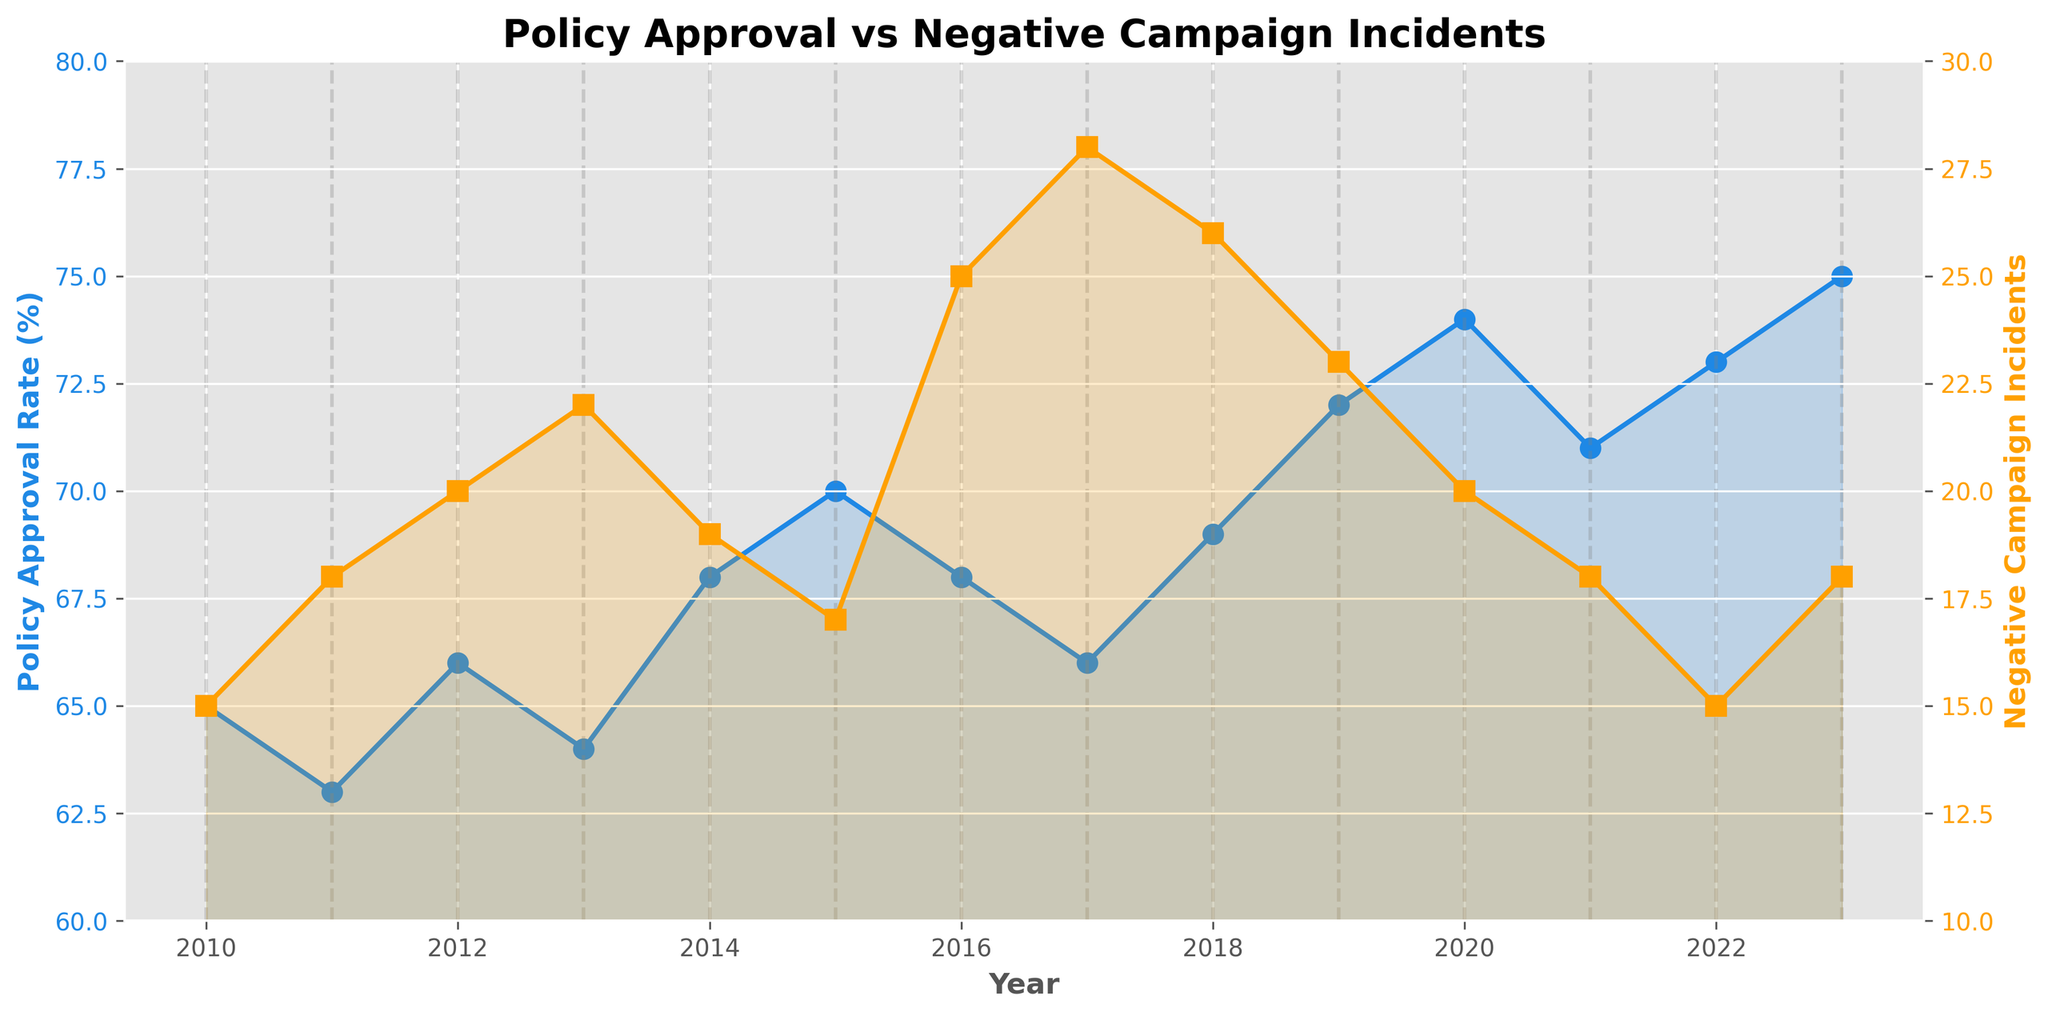What's the title of the figure? The title of the figure is placed at the top.
Answer: Policy Approval vs Negative Campaign Incidents What are the two y-axes representing? The left y-axis (colored in blue) represents the Policy Approval Rate (%), and the right y-axis (colored in orange) represents the Number of Negative Campaign Incidents.
Answer: Policy Approval Rate (%) and Negative Campaign Incidents In which year was the policy approval rate highest? Look at the highest point of the blue line (Policy Approval Rate) and check the corresponding year on the x-axis.
Answer: 2023 How did the number of negative campaign incidents change between 2010 and 2013? Find the points for 2010 and 2013 on the orange line (Negative Campaign Incidents) and note their values. Compare the two values to see the change.
Answer: Increased from 15 to 22 What is the average policy approval rate over the years shown? Add all the Policy Approval Rate values and divide by the number of years (14).
Answer: (65+63+66+64+68+70+68+66+69+72+74+71+73+75) / 14 = 68.5 Which year had the lowest number of negative campaign incidents? Identify the lowest point on the orange line and note the corresponding year on the x-axis.
Answer: 2010 Was the policy approval rate generally trending upwards or downwards? Observe the general direction of the blue line. If it moves higher as the years progress, it trends upwards; otherwise, it trends downwards.
Answer: Upwards What was the difference in policy approval rate between the year with the highest incidents of negative campaigns and the year with the lowest incidents? Find the years with the highest and lowest orange line points, then note their corresponding policy approval rates. Subtract the two rates.
Answer: 2023 (75) - 2010 (65) = 10 